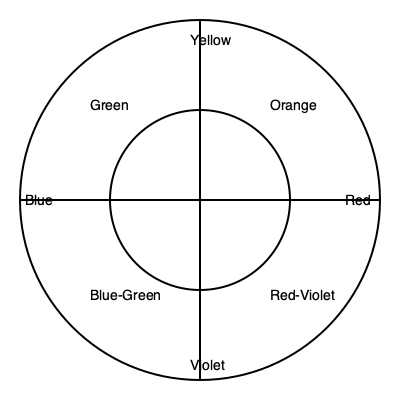In Ukrainian folk-inspired embroidery, which color would create the strongest contrast and complement a predominantly red design? To determine the color that would create the strongest contrast and complement a predominantly red design in Ukrainian folk-inspired embroidery, we need to understand the concept of complementary colors:

1. Complementary colors are pairs of colors that are opposite each other on the color wheel.
2. In the given color wheel, we can see that red is located on the right side.
3. The color directly opposite red on the color wheel is green.
4. Complementary colors create the strongest contrast when used together.
5. In Ukrainian folk embroidery, contrasting colors are often used to create bold, eye-catching designs.
6. Using green as a complement to red would create a vibrant, high-contrast effect that is characteristic of many Ukrainian folk textile patterns.
7. This combination would make the red elements stand out more prominently against the green, and vice versa.

Therefore, green would create the strongest contrast and complement a predominantly red design in Ukrainian folk-inspired embroidery.
Answer: Green 